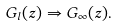<formula> <loc_0><loc_0><loc_500><loc_500>G _ { l } ( z ) \Rightarrow G _ { \infty } ( z ) .</formula> 